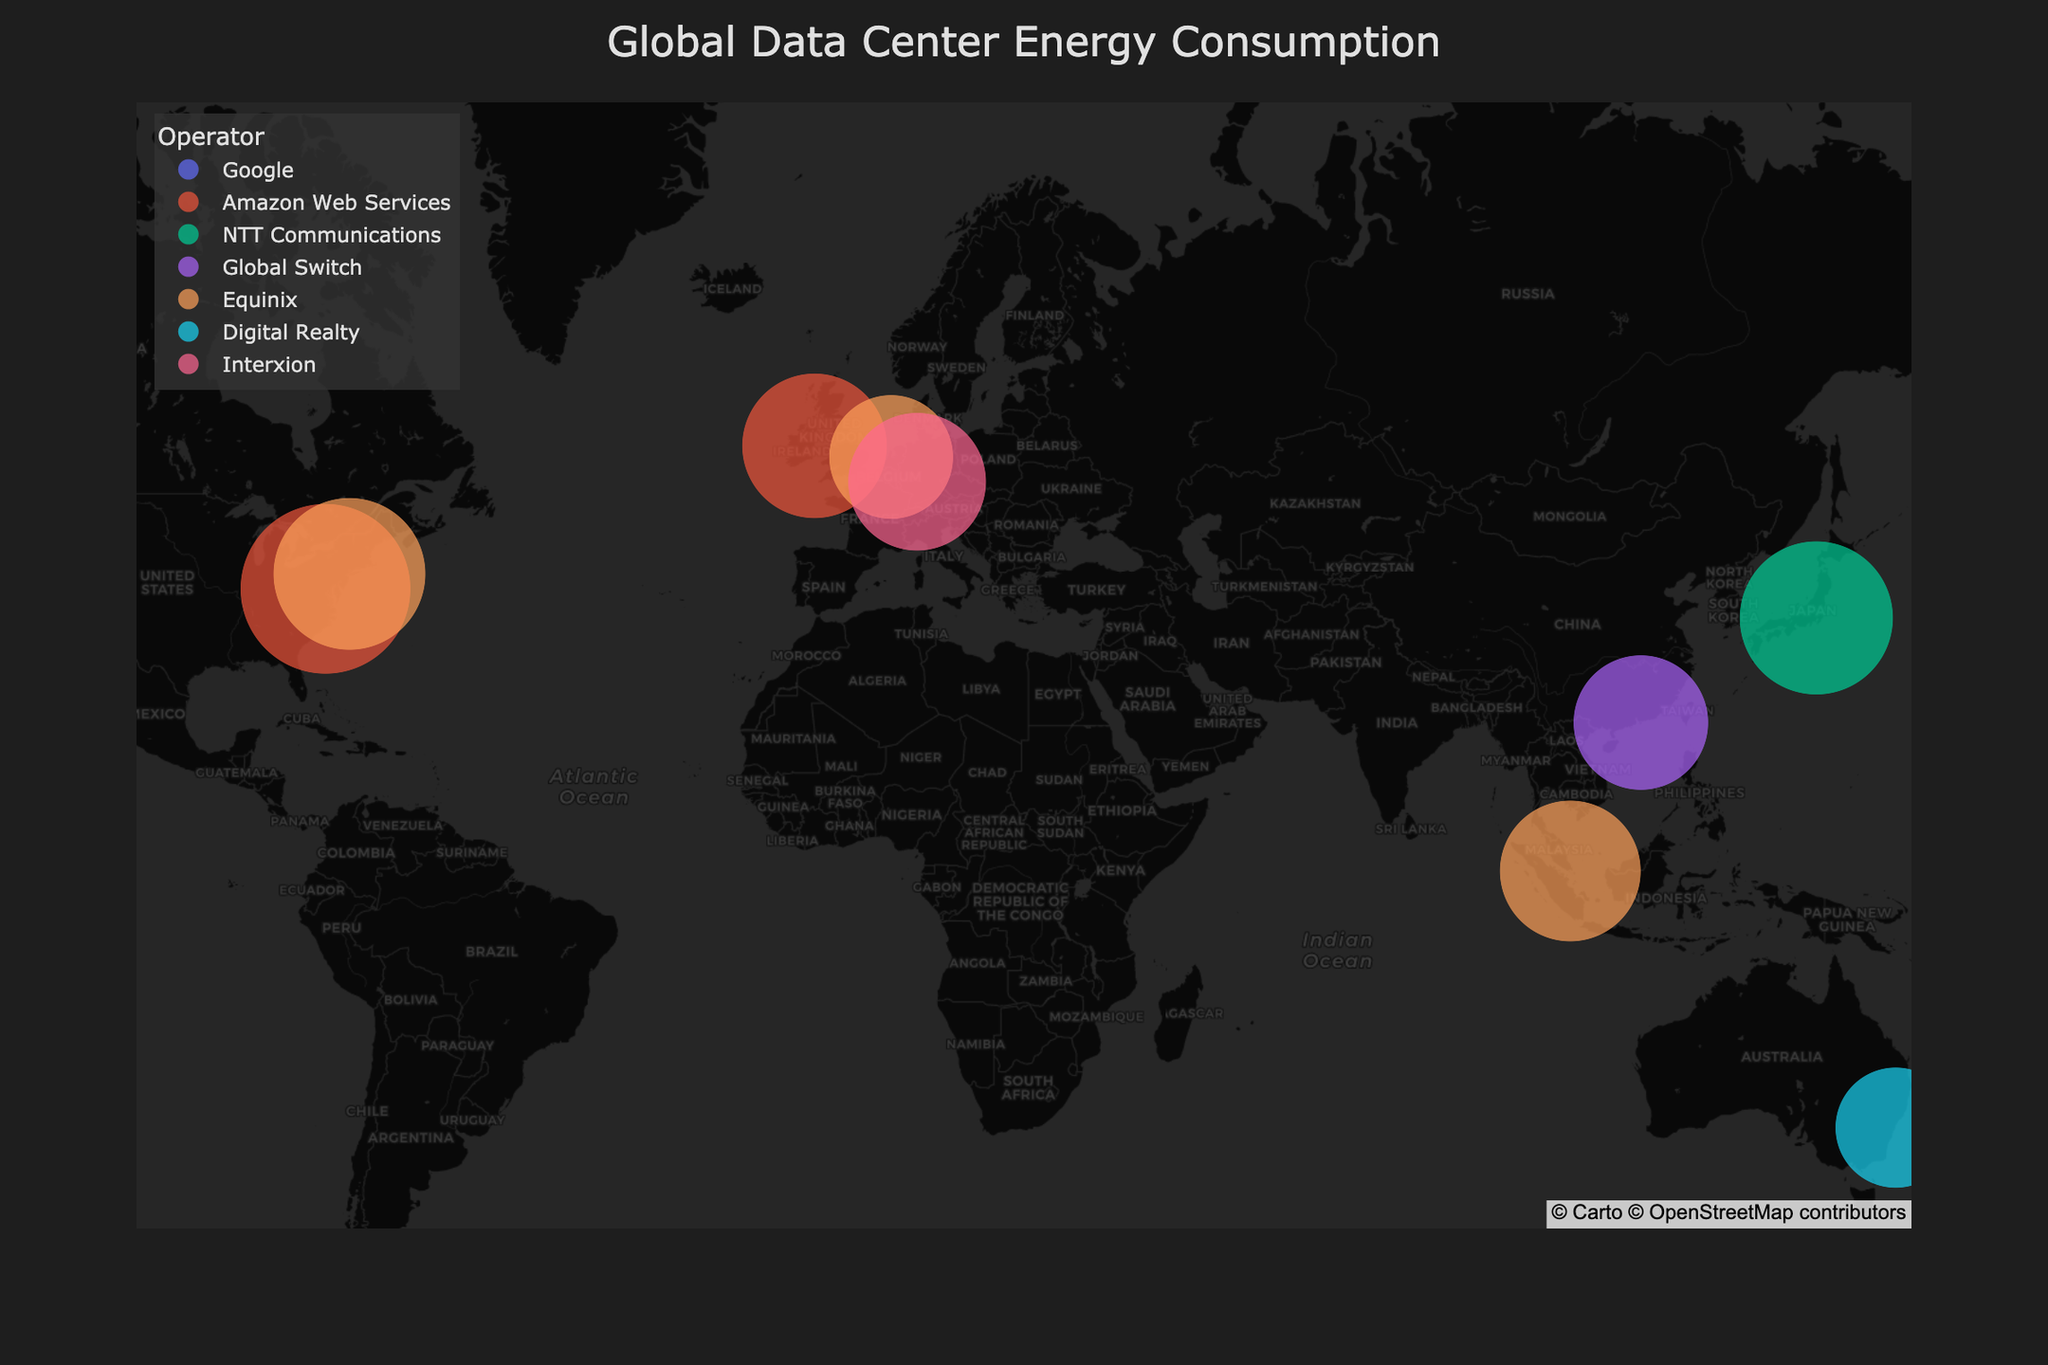Which data center has the highest energy consumption? Look at the data points on the map and identify the center with the largest marker size. Ashburn VA3 in Ashburn, VA, USA has the highest energy consumption of 1,350,000 MWh.
Answer: Ashburn VA3 What is the title of the figure? The title is displayed at the top center of the figure in large, bold text. The title is "Global Data Center Energy Consumption".
Answer: Global Data Center Energy Consumption How many operators have data centers on the map? Observe the legend that lists the operators, each represented by a different color. There are 6 operators on the map: Google, Amazon Web Services, NTT Communications, Global Switch, Equinix, and Digital Realty.
Answer: 6 Which data center has the lowest energy consumption and how much is it? Identify the center with the smallest marker size. Sydney SYD5 in Sydney, Australia uses the least energy, consuming 680,000 MWh.
Answer: Sydney SYD5, 680,000 MWh What is the total energy consumption of data centers operated by Amazon Web Services? Find the data centers operated by Amazon Web Services and add their energy consumption figures. Ashburn VA3 consumes 1,350,000 MWh and Amazon Dublin consumes 980,000 MWh, totaling 2,330,000 MWh.
Answer: 2,330,000 MWh Compare the energy consumption between Google Sunnyvale and Tokyo Data Center. Which one uses more energy and by how much? Find the energy consumption of both data centers and calculate the difference. Google Sunnyvale consumes 1,250,000 MWh, while Tokyo Data Center uses 1,100,000 MWh. Google Sunnyvale consumes 150,000 MWh more.
Answer: Google Sunnyvale, 150,000 MWh Which continents have the highest concentration of data centers in the figure? Examine the geographic locations of data centers marked on the map. North America (USA) and Europe (Ireland, Netherlands, Germany) have the highest concentrations of data centers.
Answer: North America and Europe What is the range of energy consumption values among the listed data centers? Identify the minimum and maximum energy consumption values from the data centers. The range is from Sydney SYD5 with 680,000 MWh to Ashburn VA3 with 1,350,000 MWh.
Answer: 680,000 MWh to 1,350,000 MWh How does the energy consumption of the Frankfurt FR5 data center compare to that of the New York NY5 data center? Locate the energy consumption figures for both data centers and compare them. Frankfurt FR5 consumes 890,000 MWh and New York NY5 consumes 1,080,000 MWh. New York NY5 uses more energy by 190,000 MWh.
Answer: New York NY5, 190,000 MWh 